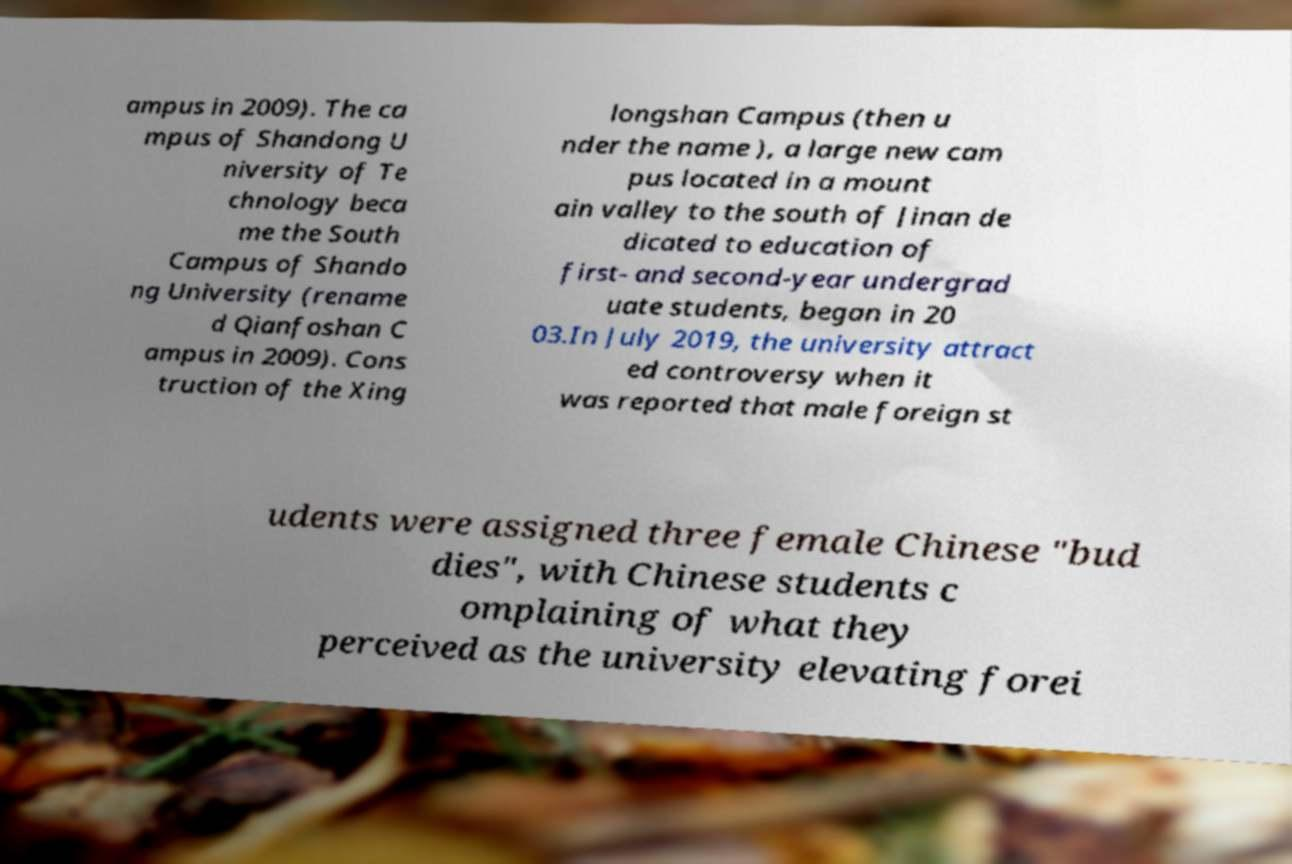Can you read and provide the text displayed in the image?This photo seems to have some interesting text. Can you extract and type it out for me? ampus in 2009). The ca mpus of Shandong U niversity of Te chnology beca me the South Campus of Shando ng University (rename d Qianfoshan C ampus in 2009). Cons truction of the Xing longshan Campus (then u nder the name ), a large new cam pus located in a mount ain valley to the south of Jinan de dicated to education of first- and second-year undergrad uate students, began in 20 03.In July 2019, the university attract ed controversy when it was reported that male foreign st udents were assigned three female Chinese "bud dies", with Chinese students c omplaining of what they perceived as the university elevating forei 